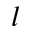<formula> <loc_0><loc_0><loc_500><loc_500>l</formula> 